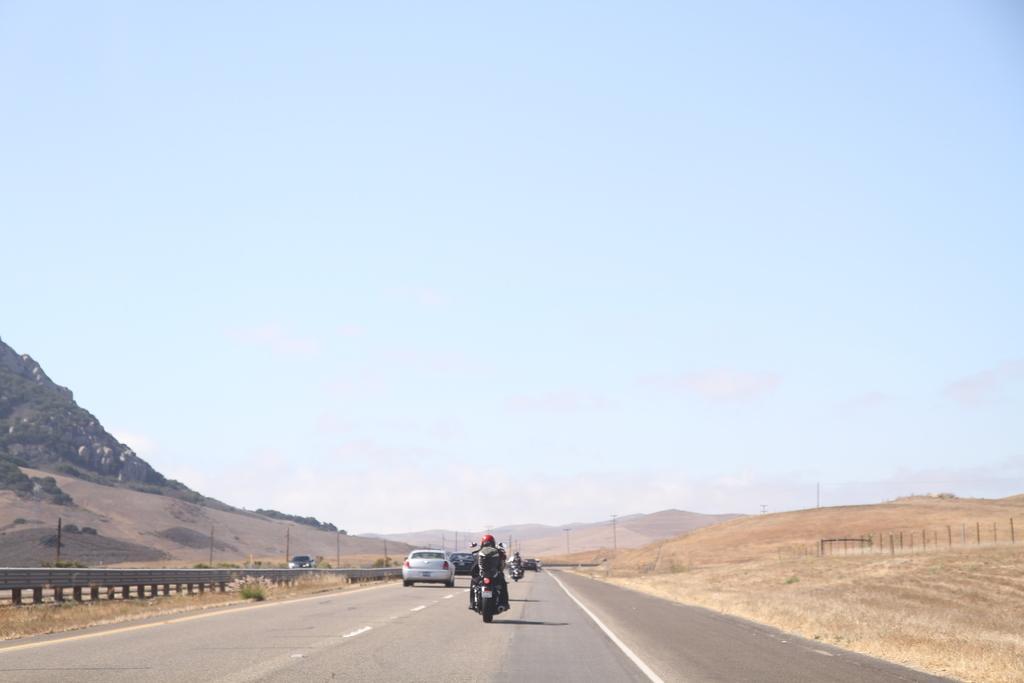How would you summarize this image in a sentence or two? This image consists of vehicles moving on the road. In the front, there is a man riding a bike. At the bottom, there is a road. On the left, there is a mountain. On the right, we can see the dry grass on the ground. At the top, there is sky. 